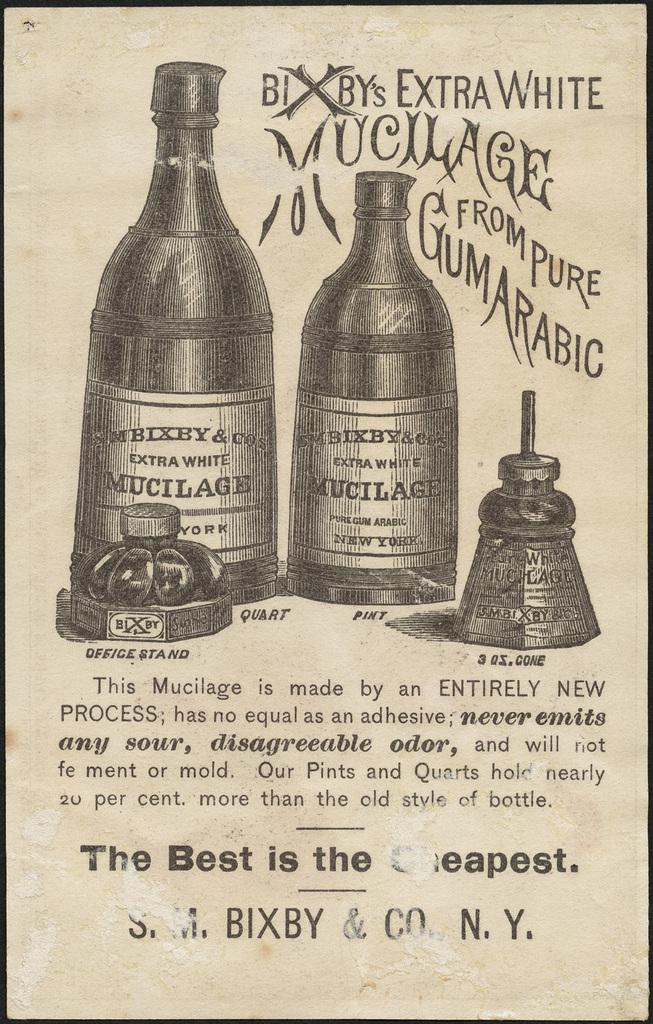The mucilage is made from pure what?
Keep it short and to the point. Gum arabic. According to this, the best is the what?
Make the answer very short. Cheapest. 